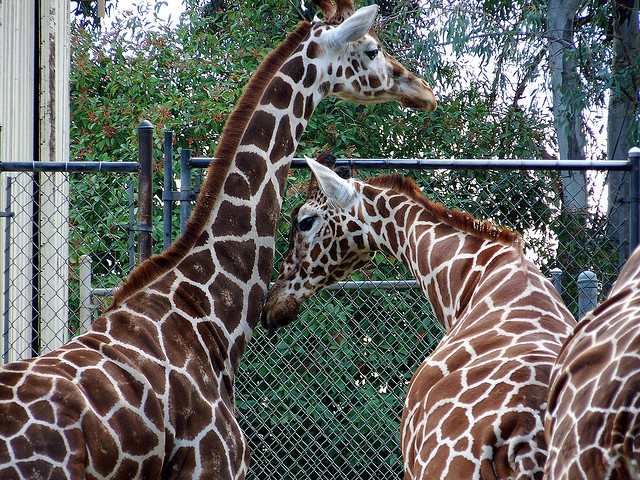Describe the objects in this image and their specific colors. I can see giraffe in purple, black, maroon, darkgray, and gray tones, giraffe in purple, brown, lightgray, black, and maroon tones, and giraffe in purple, brown, darkgray, gray, and lightgray tones in this image. 